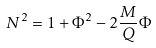<formula> <loc_0><loc_0><loc_500><loc_500>N ^ { 2 } & = 1 + \Phi ^ { 2 } - 2 \frac { M } { Q } \Phi</formula> 